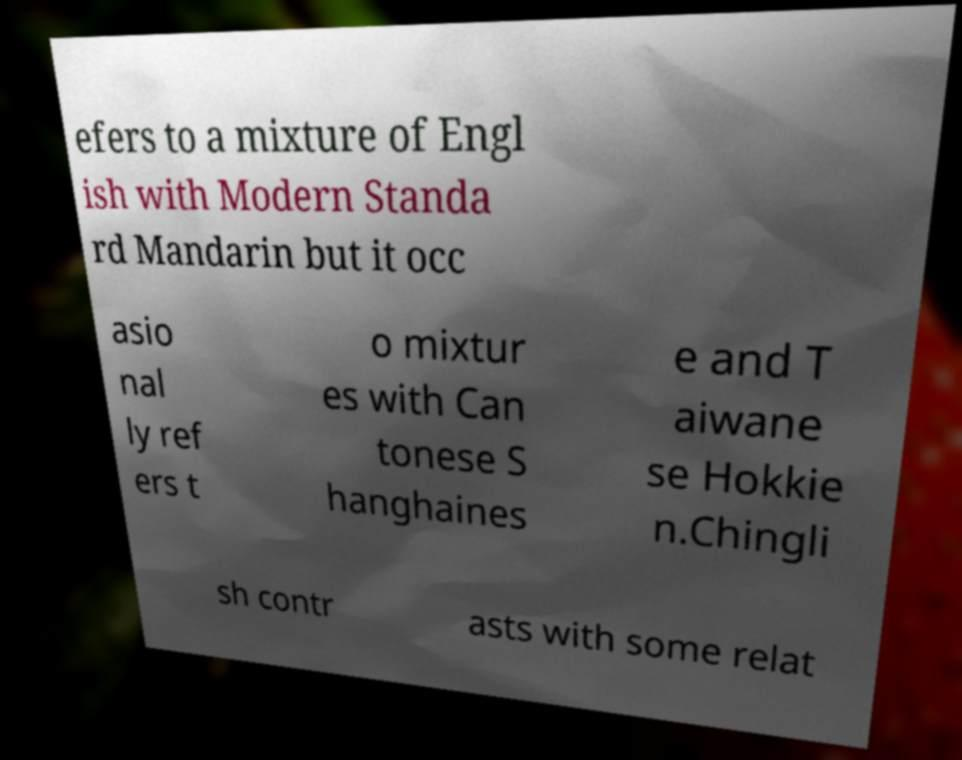Please identify and transcribe the text found in this image. efers to a mixture of Engl ish with Modern Standa rd Mandarin but it occ asio nal ly ref ers t o mixtur es with Can tonese S hanghaines e and T aiwane se Hokkie n.Chingli sh contr asts with some relat 